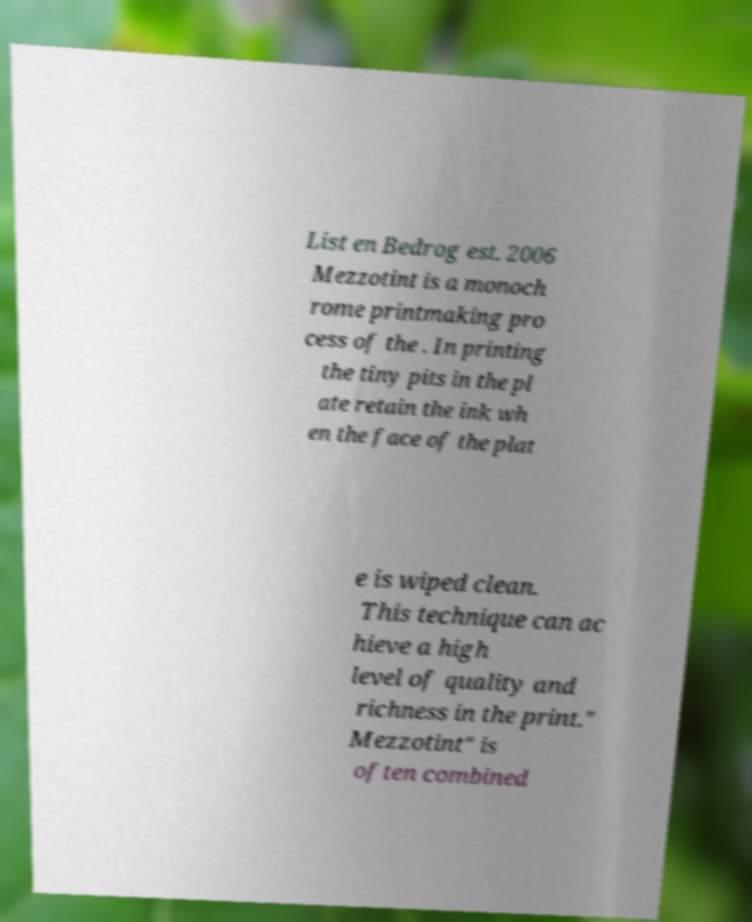Could you assist in decoding the text presented in this image and type it out clearly? List en Bedrog est. 2006 Mezzotint is a monoch rome printmaking pro cess of the . In printing the tiny pits in the pl ate retain the ink wh en the face of the plat e is wiped clean. This technique can ac hieve a high level of quality and richness in the print." Mezzotint" is often combined 